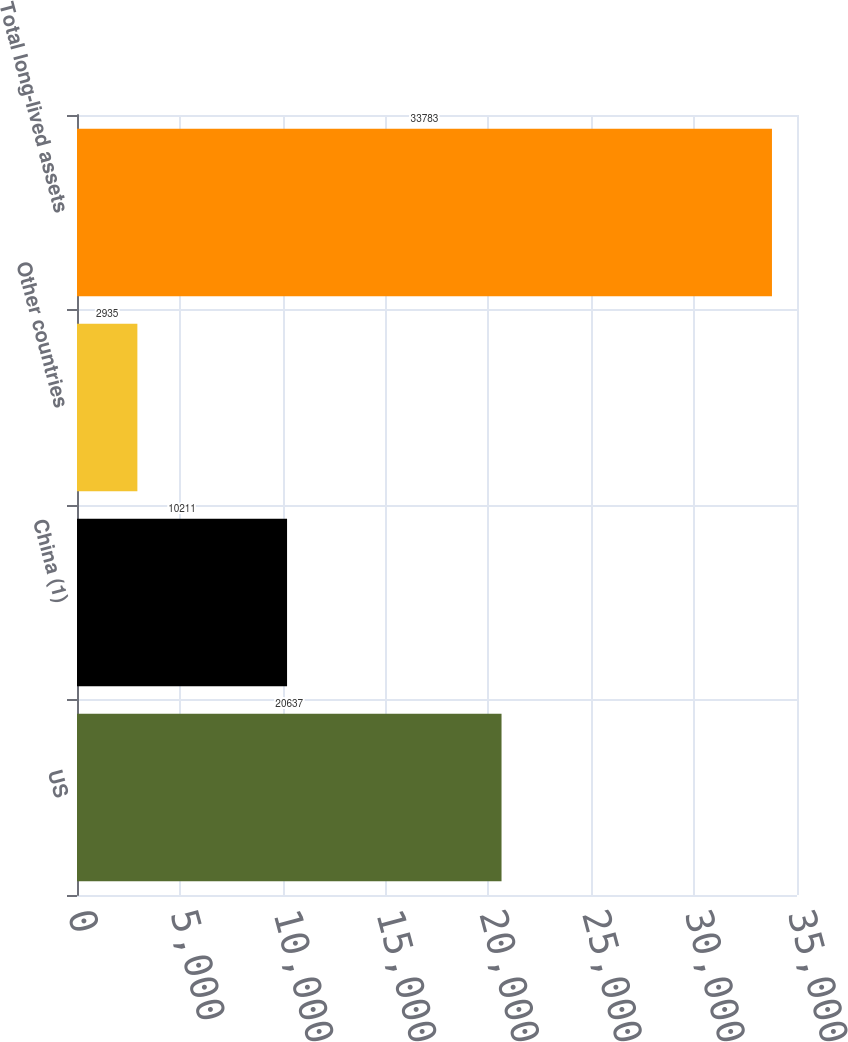Convert chart. <chart><loc_0><loc_0><loc_500><loc_500><bar_chart><fcel>US<fcel>China (1)<fcel>Other countries<fcel>Total long-lived assets<nl><fcel>20637<fcel>10211<fcel>2935<fcel>33783<nl></chart> 